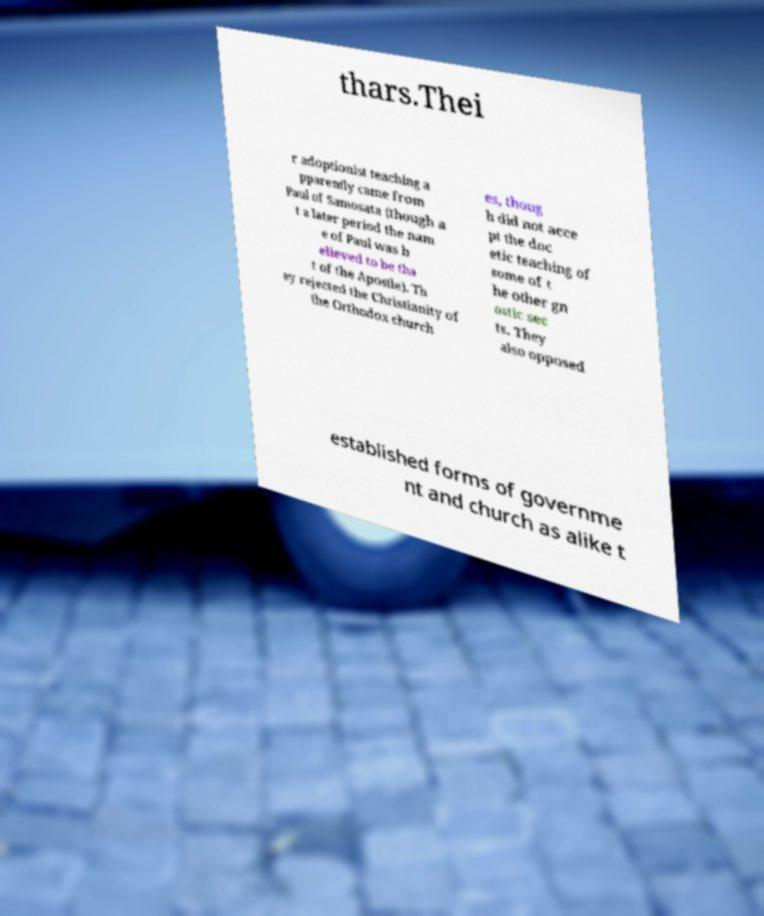I need the written content from this picture converted into text. Can you do that? thars.Thei r adoptionist teaching a pparently came from Paul of Samosata (though a t a later period the nam e of Paul was b elieved to be tha t of the Apostle). Th ey rejected the Christianity of the Orthodox church es, thoug h did not acce pt the doc etic teaching of some of t he other gn ostic sec ts. They also opposed established forms of governme nt and church as alike t 